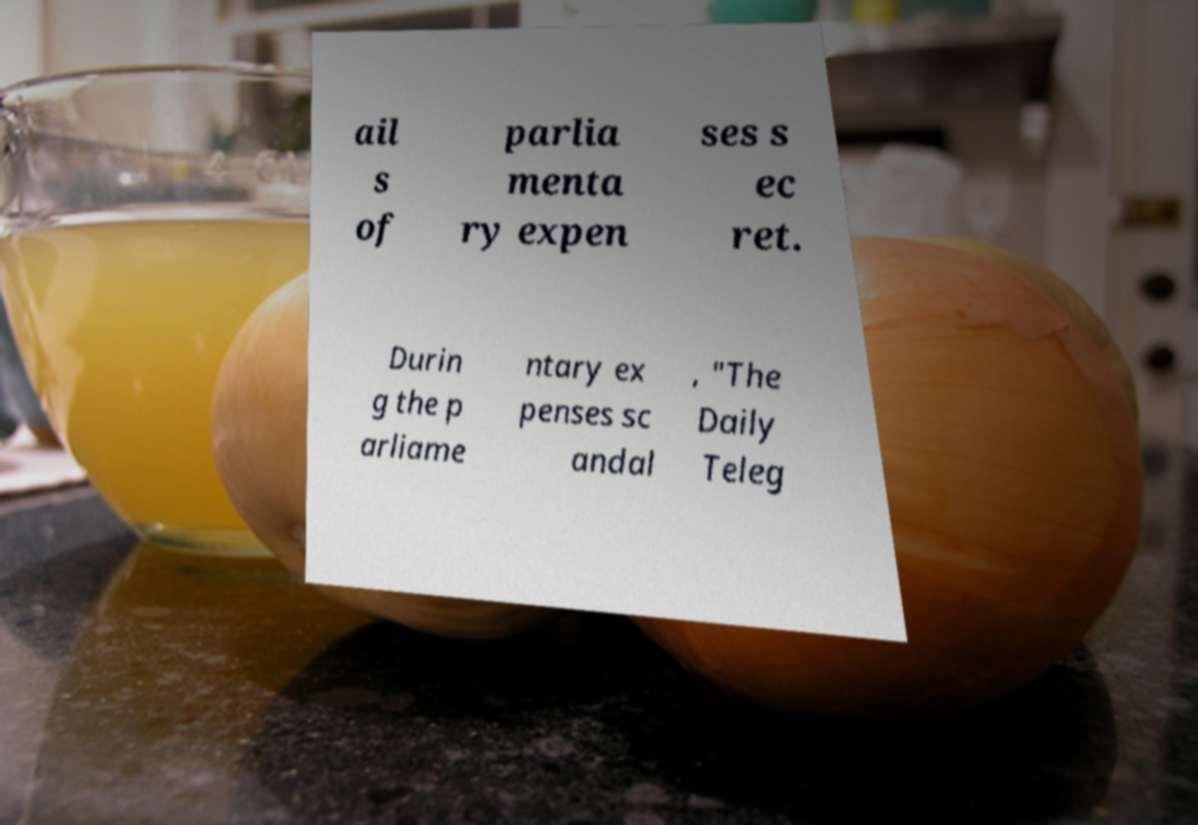Can you accurately transcribe the text from the provided image for me? ail s of parlia menta ry expen ses s ec ret. Durin g the p arliame ntary ex penses sc andal , "The Daily Teleg 